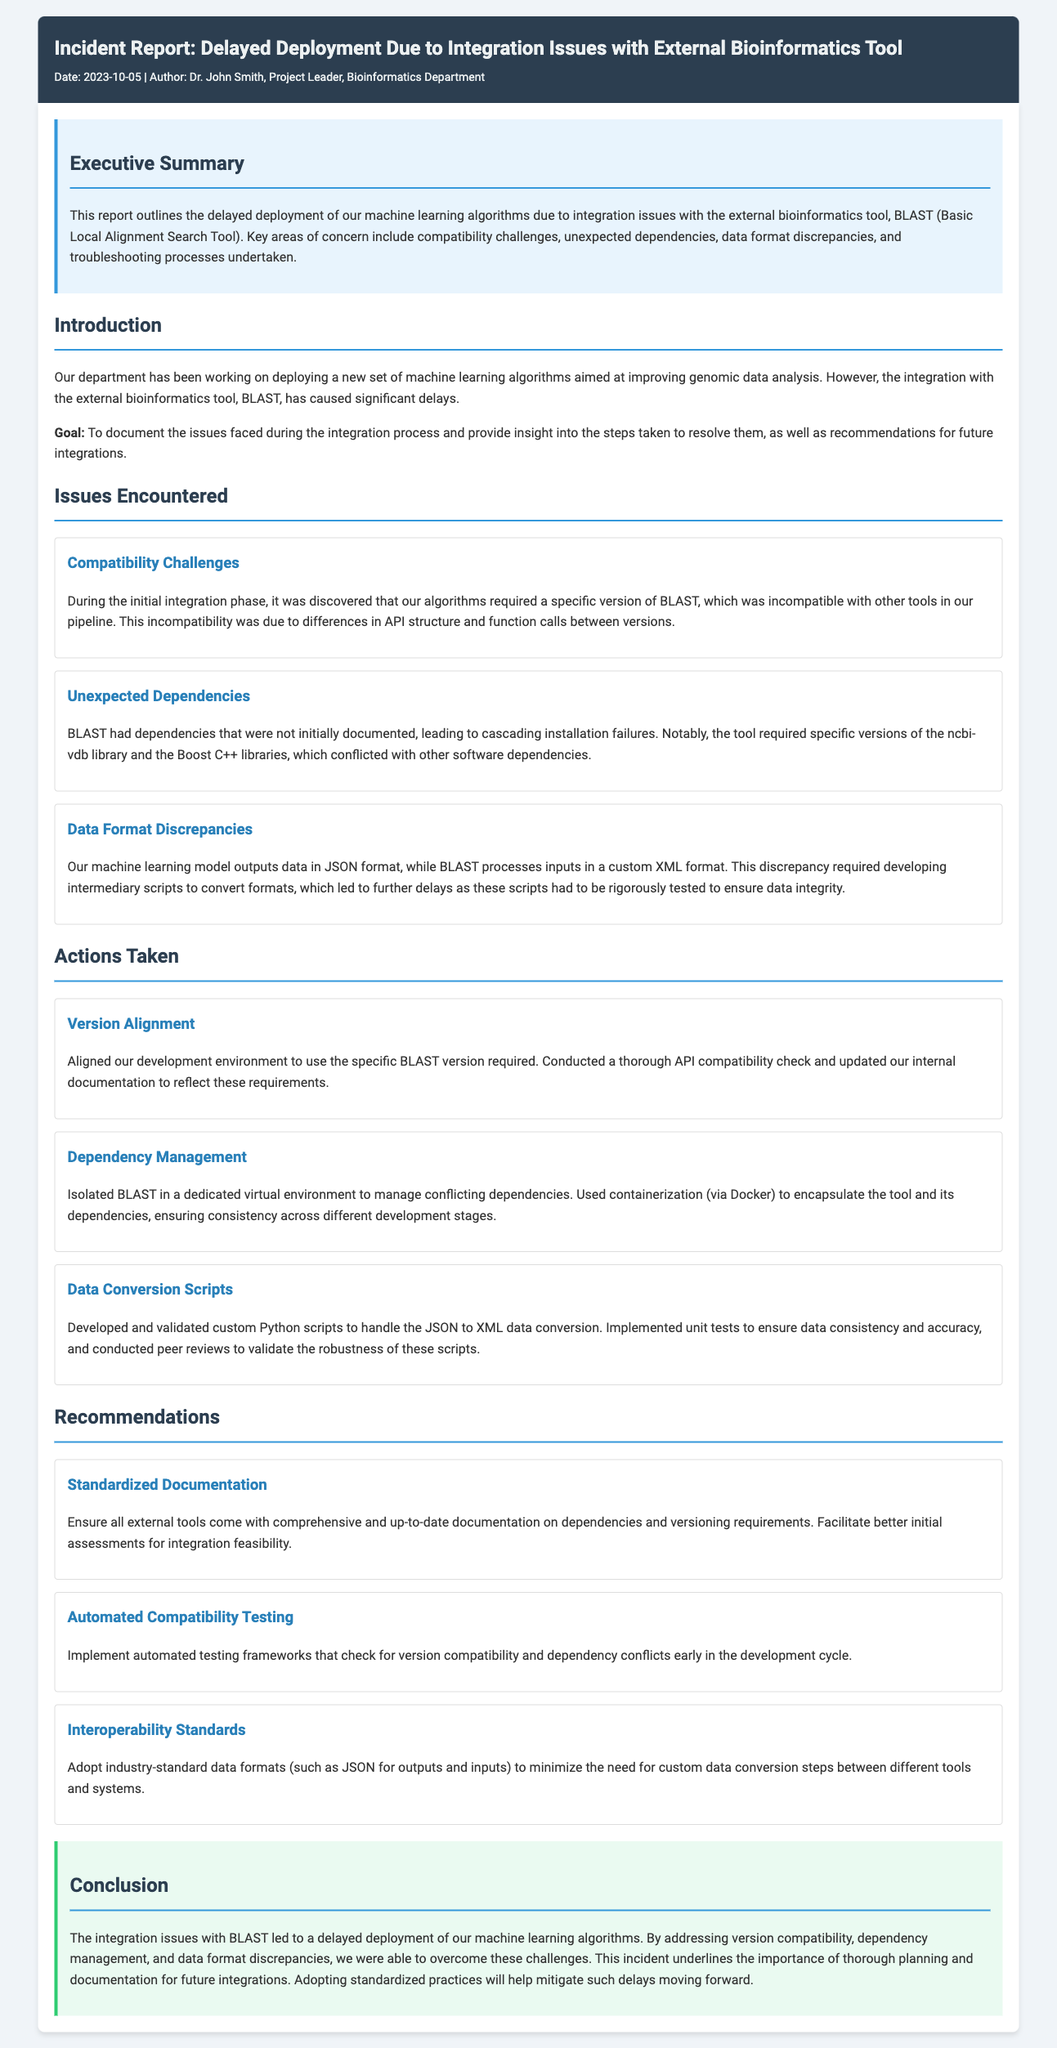What is the date of the incident report? The date is specified in the header of the report.
Answer: 2023-10-05 Who authored the incident report? The author is mentioned in the header section.
Answer: Dr. John Smith What external bioinformatics tool was involved in the delay? The report specifies the tool that caused the delay in deployment.
Answer: BLAST What is one of the main compatibility challenges mentioned? The compatibility challenge is described in the "Issues Encountered" section.
Answer: API structure What library was specifically noted for causing unexpected dependencies? The report highlights a specific library that led to installation failures.
Answer: ncbi-vdb What action was taken regarding version alignment? The actions taken are documented under "Actions Taken."
Answer: Aligned our development environment Which programming language was used for developing the data conversion scripts? The section on "Data Conversion Scripts" indicates the language used.
Answer: Python What is a recommendation for improving future integrations? The recommendations section provides suggestions for future practices.
Answer: Standardized Documentation What was the primary reason for the delayed deployment? The executive summary outlines the main reason for the delay.
Answer: Integration issues 